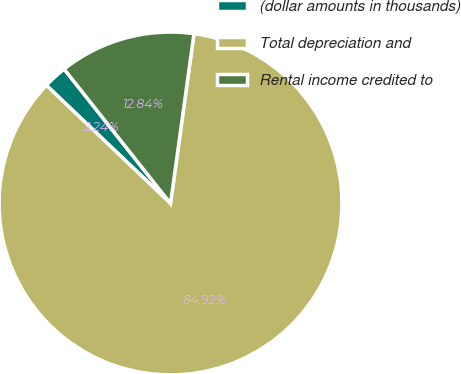Convert chart to OTSL. <chart><loc_0><loc_0><loc_500><loc_500><pie_chart><fcel>(dollar amounts in thousands)<fcel>Total depreciation and<fcel>Rental income credited to<nl><fcel>2.24%<fcel>84.92%<fcel>12.84%<nl></chart> 